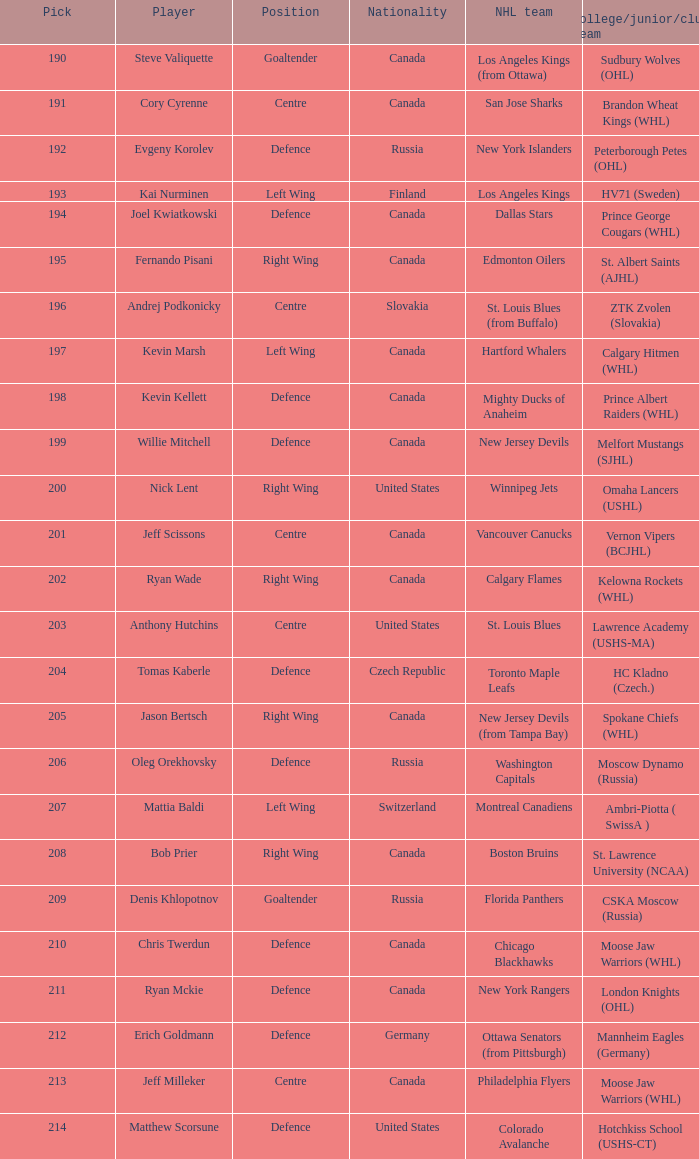Identify the educational institution for andrej podkonicky. ZTK Zvolen (Slovakia). 